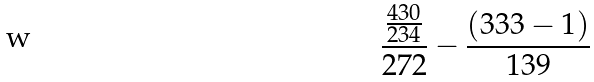Convert formula to latex. <formula><loc_0><loc_0><loc_500><loc_500>\frac { \frac { 4 3 0 } { 2 3 4 } } { 2 7 2 } - \frac { ( 3 3 3 - 1 ) } { 1 3 9 }</formula> 